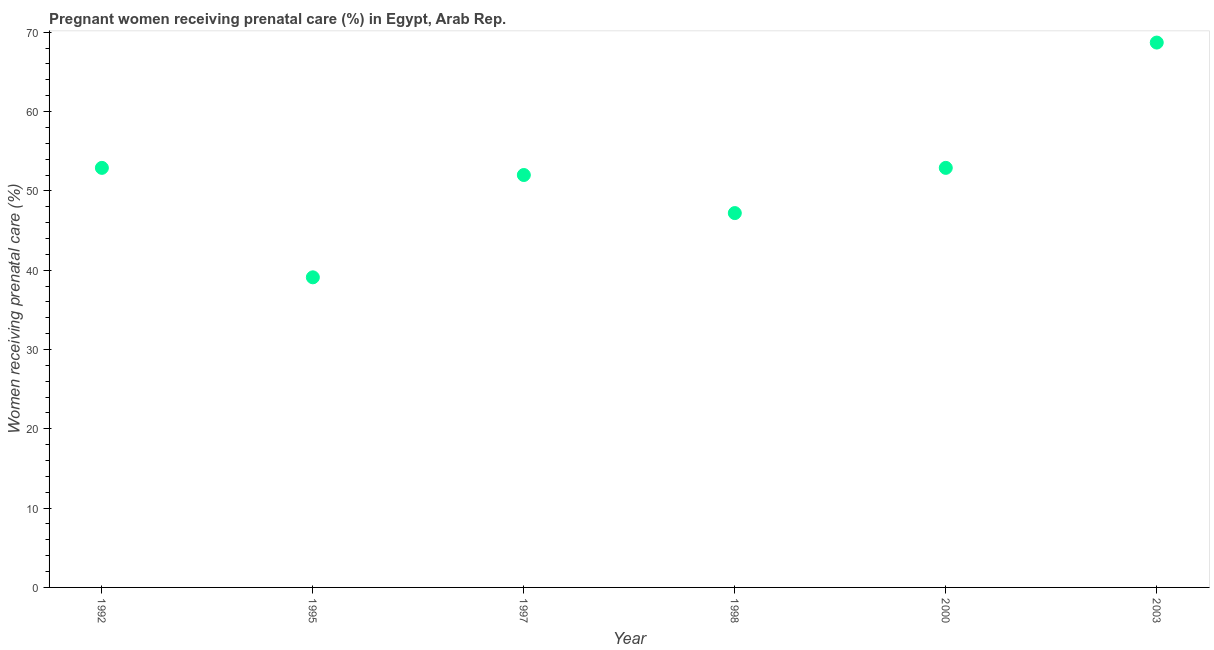What is the percentage of pregnant women receiving prenatal care in 1997?
Give a very brief answer. 52. Across all years, what is the maximum percentage of pregnant women receiving prenatal care?
Provide a short and direct response. 68.7. Across all years, what is the minimum percentage of pregnant women receiving prenatal care?
Ensure brevity in your answer.  39.1. In which year was the percentage of pregnant women receiving prenatal care minimum?
Offer a very short reply. 1995. What is the sum of the percentage of pregnant women receiving prenatal care?
Your response must be concise. 312.8. What is the difference between the percentage of pregnant women receiving prenatal care in 1992 and 1995?
Provide a succinct answer. 13.8. What is the average percentage of pregnant women receiving prenatal care per year?
Provide a succinct answer. 52.13. What is the median percentage of pregnant women receiving prenatal care?
Your answer should be compact. 52.45. In how many years, is the percentage of pregnant women receiving prenatal care greater than 22 %?
Make the answer very short. 6. What is the ratio of the percentage of pregnant women receiving prenatal care in 1992 to that in 2000?
Keep it short and to the point. 1. Is the percentage of pregnant women receiving prenatal care in 1998 less than that in 2003?
Ensure brevity in your answer.  Yes. Is the difference between the percentage of pregnant women receiving prenatal care in 1995 and 1998 greater than the difference between any two years?
Provide a succinct answer. No. What is the difference between the highest and the second highest percentage of pregnant women receiving prenatal care?
Your answer should be very brief. 15.8. Is the sum of the percentage of pregnant women receiving prenatal care in 1997 and 2003 greater than the maximum percentage of pregnant women receiving prenatal care across all years?
Offer a terse response. Yes. What is the difference between the highest and the lowest percentage of pregnant women receiving prenatal care?
Make the answer very short. 29.6. Are the values on the major ticks of Y-axis written in scientific E-notation?
Provide a short and direct response. No. Does the graph contain grids?
Ensure brevity in your answer.  No. What is the title of the graph?
Your answer should be very brief. Pregnant women receiving prenatal care (%) in Egypt, Arab Rep. What is the label or title of the X-axis?
Your answer should be very brief. Year. What is the label or title of the Y-axis?
Offer a terse response. Women receiving prenatal care (%). What is the Women receiving prenatal care (%) in 1992?
Provide a short and direct response. 52.9. What is the Women receiving prenatal care (%) in 1995?
Offer a very short reply. 39.1. What is the Women receiving prenatal care (%) in 1998?
Make the answer very short. 47.2. What is the Women receiving prenatal care (%) in 2000?
Make the answer very short. 52.9. What is the Women receiving prenatal care (%) in 2003?
Keep it short and to the point. 68.7. What is the difference between the Women receiving prenatal care (%) in 1992 and 1997?
Your answer should be very brief. 0.9. What is the difference between the Women receiving prenatal care (%) in 1992 and 2003?
Ensure brevity in your answer.  -15.8. What is the difference between the Women receiving prenatal care (%) in 1995 and 1998?
Give a very brief answer. -8.1. What is the difference between the Women receiving prenatal care (%) in 1995 and 2000?
Make the answer very short. -13.8. What is the difference between the Women receiving prenatal care (%) in 1995 and 2003?
Make the answer very short. -29.6. What is the difference between the Women receiving prenatal care (%) in 1997 and 2000?
Make the answer very short. -0.9. What is the difference between the Women receiving prenatal care (%) in 1997 and 2003?
Give a very brief answer. -16.7. What is the difference between the Women receiving prenatal care (%) in 1998 and 2003?
Make the answer very short. -21.5. What is the difference between the Women receiving prenatal care (%) in 2000 and 2003?
Offer a very short reply. -15.8. What is the ratio of the Women receiving prenatal care (%) in 1992 to that in 1995?
Your answer should be compact. 1.35. What is the ratio of the Women receiving prenatal care (%) in 1992 to that in 1997?
Offer a terse response. 1.02. What is the ratio of the Women receiving prenatal care (%) in 1992 to that in 1998?
Ensure brevity in your answer.  1.12. What is the ratio of the Women receiving prenatal care (%) in 1992 to that in 2003?
Offer a very short reply. 0.77. What is the ratio of the Women receiving prenatal care (%) in 1995 to that in 1997?
Ensure brevity in your answer.  0.75. What is the ratio of the Women receiving prenatal care (%) in 1995 to that in 1998?
Give a very brief answer. 0.83. What is the ratio of the Women receiving prenatal care (%) in 1995 to that in 2000?
Give a very brief answer. 0.74. What is the ratio of the Women receiving prenatal care (%) in 1995 to that in 2003?
Keep it short and to the point. 0.57. What is the ratio of the Women receiving prenatal care (%) in 1997 to that in 1998?
Offer a terse response. 1.1. What is the ratio of the Women receiving prenatal care (%) in 1997 to that in 2000?
Ensure brevity in your answer.  0.98. What is the ratio of the Women receiving prenatal care (%) in 1997 to that in 2003?
Make the answer very short. 0.76. What is the ratio of the Women receiving prenatal care (%) in 1998 to that in 2000?
Make the answer very short. 0.89. What is the ratio of the Women receiving prenatal care (%) in 1998 to that in 2003?
Your answer should be compact. 0.69. What is the ratio of the Women receiving prenatal care (%) in 2000 to that in 2003?
Your response must be concise. 0.77. 